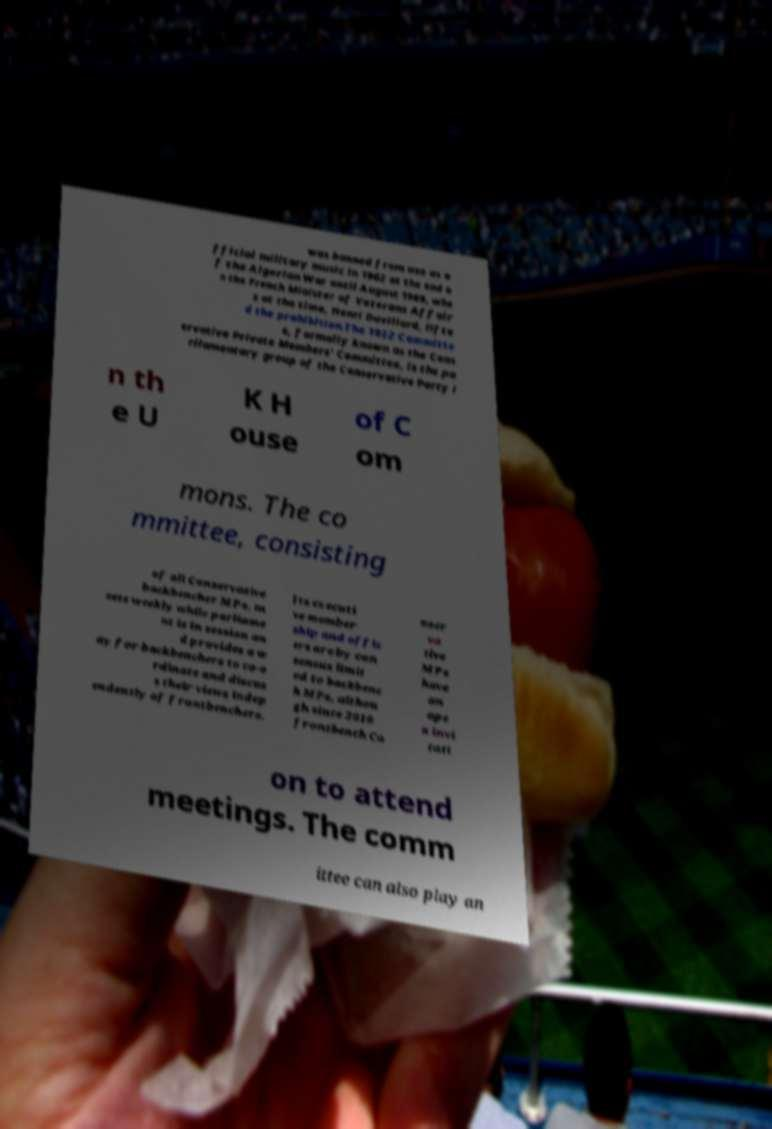Can you read and provide the text displayed in the image?This photo seems to have some interesting text. Can you extract and type it out for me? was banned from use as o fficial military music in 1962 at the end o f the Algerian War until August 1969, whe n the French Minister of Veterans Affair s at the time, Henri Duvillard, lifte d the prohibition.The 1922 Committe e, formally known as the Cons ervative Private Members' Committee, is the pa rliamentary group of the Conservative Party i n th e U K H ouse of C om mons. The co mmittee, consisting of all Conservative backbencher MPs, m eets weekly while parliame nt is in session an d provides a w ay for backbenchers to co-o rdinate and discus s their views indep endently of frontbenchers. Its executi ve member ship and offic ers are by con sensus limit ed to backbenc h MPs, althou gh since 2010 frontbench Co nser va tive MPs have an ope n invi tati on to attend meetings. The comm ittee can also play an 